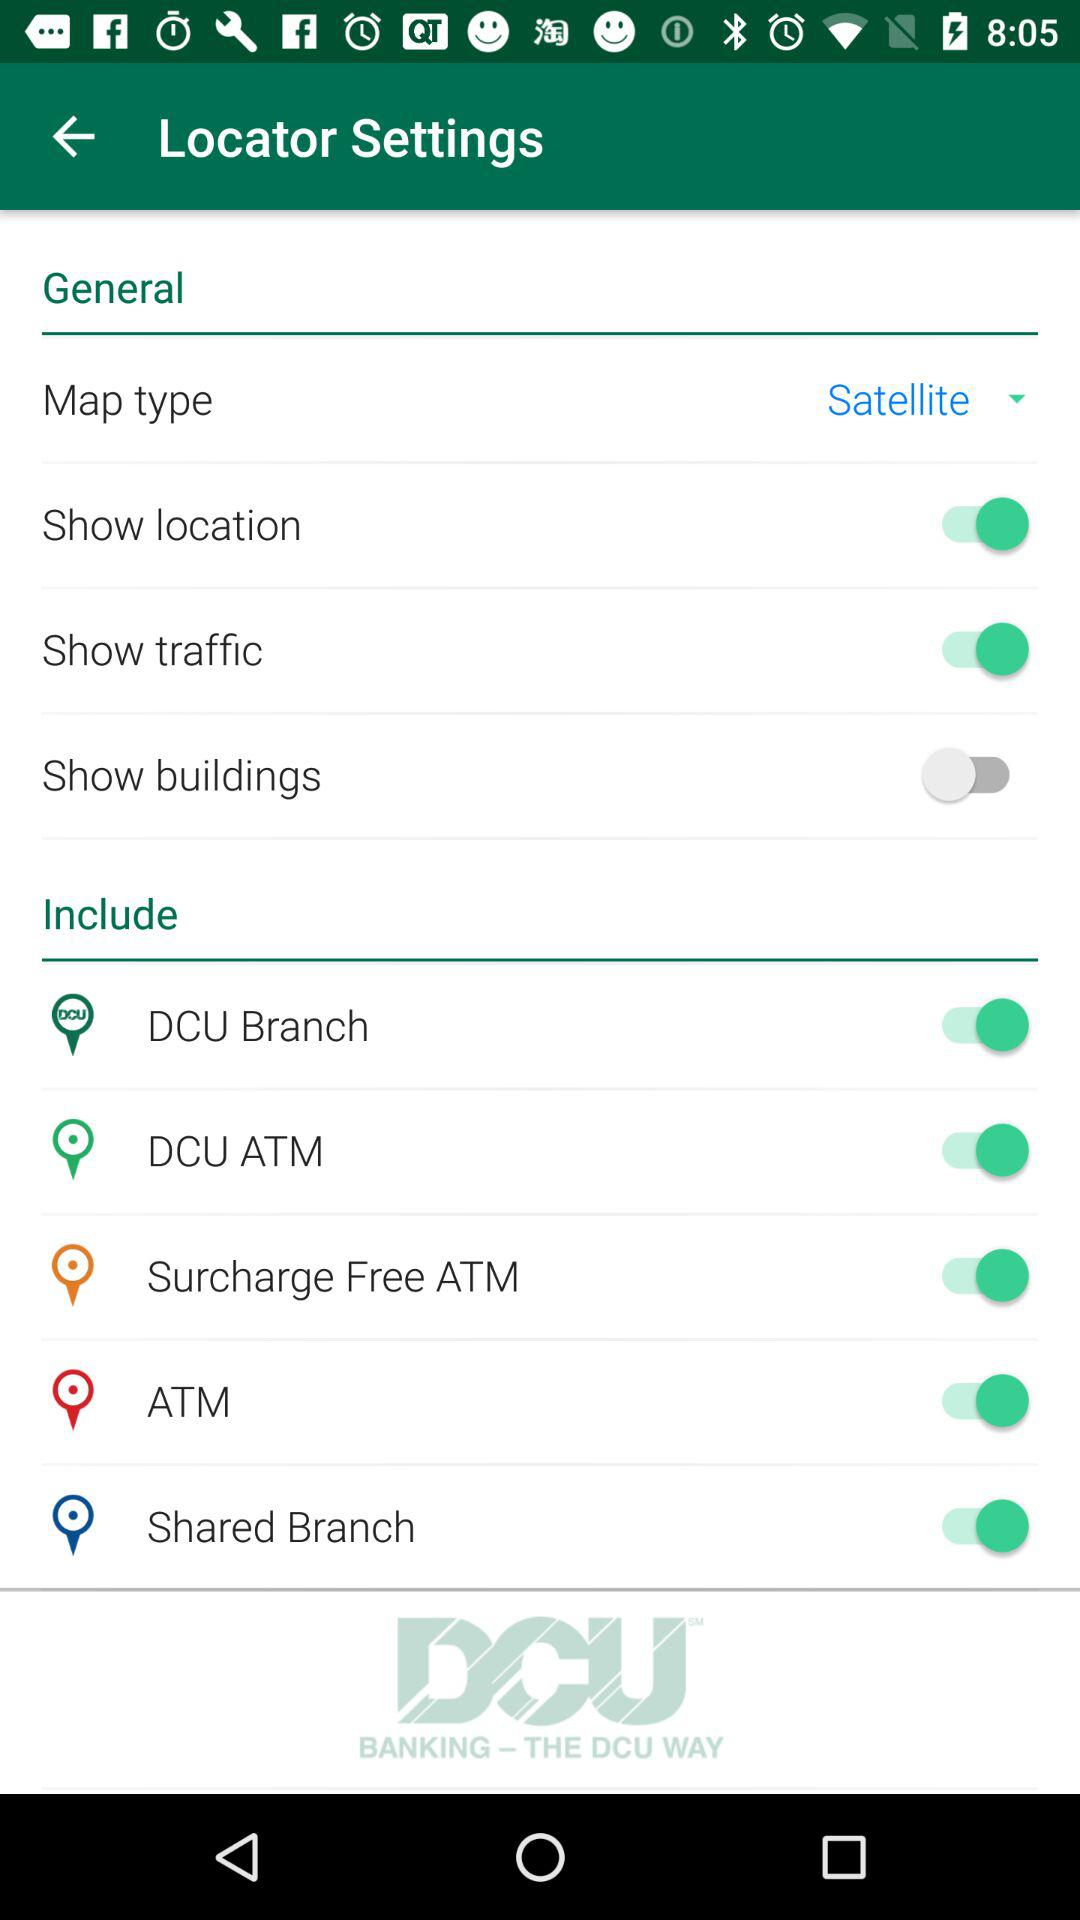What is the selected map type? The selected map type is Satellite. 